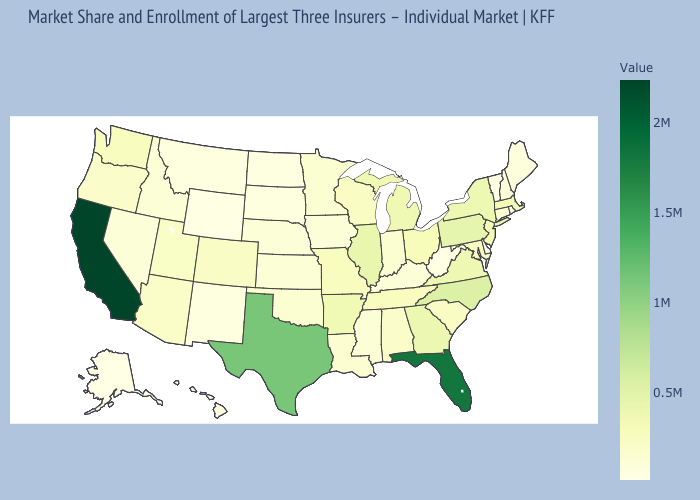Does South Carolina have a higher value than California?
Write a very short answer. No. Which states have the lowest value in the South?
Answer briefly. Delaware. Which states have the lowest value in the MidWest?
Write a very short answer. North Dakota. Is the legend a continuous bar?
Concise answer only. Yes. Does West Virginia have the lowest value in the USA?
Give a very brief answer. No. Which states have the highest value in the USA?
Give a very brief answer. California. 